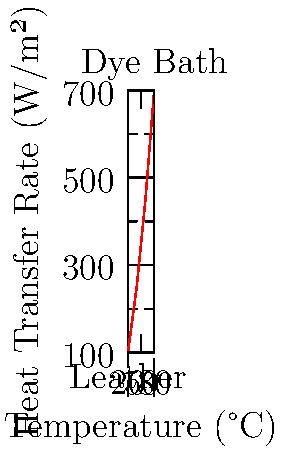In a leather dyeing process, the heat transfer rate increases with temperature as shown in the graph. If the leather temperature is 20°C and the dye bath is maintained at 80°C, what is the approximate heat transfer rate (in W/m²) at the midpoint temperature of 50°C? To solve this problem, we'll follow these steps:

1. Identify the temperature range:
   - Initial temperature (leather): $T_1 = 20°C$
   - Final temperature (dye bath): $T_2 = 80°C$
   - Midpoint temperature: $T_m = \frac{T_1 + T_2}{2} = \frac{20 + 80}{2} = 50°C$

2. Locate the heat transfer rates at the endpoints:
   - At 20°C: $q_1 \approx 100$ W/m²
   - At 80°C: $q_2 \approx 700$ W/m²

3. Assume a linear relationship between temperature and heat transfer rate:
   $q = m(T - T_1) + q_1$
   where $m$ is the slope of the line.

4. Calculate the slope:
   $m = \frac{q_2 - q_1}{T_2 - T_1} = \frac{700 - 100}{80 - 20} = \frac{600}{60} = 10$ W/m²/°C

5. Use the linear equation to find the heat transfer rate at 50°C:
   $q = 10(50 - 20) + 100 = 10(30) + 100 = 300 + 100 = 400$ W/m²

Therefore, the approximate heat transfer rate at 50°C is 400 W/m².
Answer: 400 W/m² 